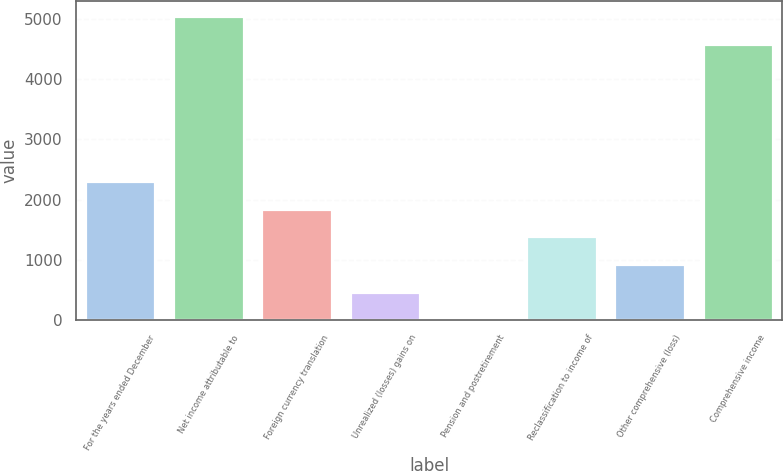Convert chart to OTSL. <chart><loc_0><loc_0><loc_500><loc_500><bar_chart><fcel>For the years ended December<fcel>Net income attributable to<fcel>Foreign currency translation<fcel>Unrealized (losses) gains on<fcel>Pension and postretirement<fcel>Reclassification to income of<fcel>Other comprehensive (loss)<fcel>Comprehensive income<nl><fcel>2306<fcel>5037.4<fcel>1847.6<fcel>472.4<fcel>14<fcel>1389.2<fcel>930.8<fcel>4579<nl></chart> 